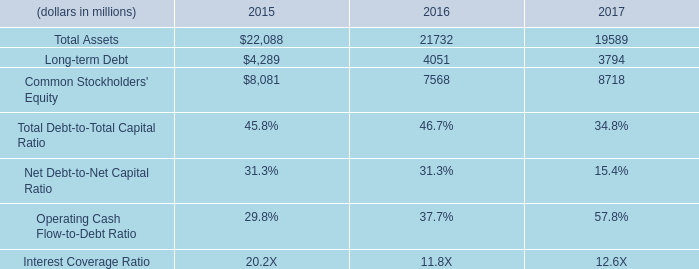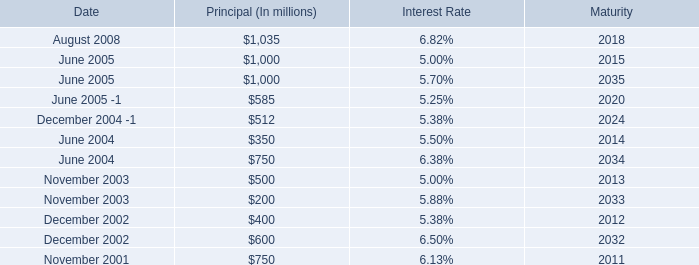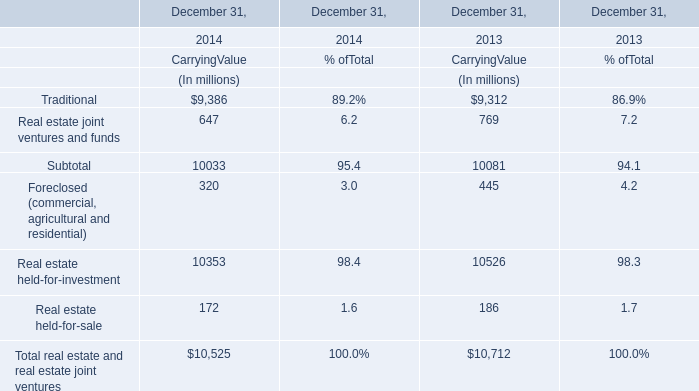What is the sum of December 2002 of Maturity, and Common Stockholders' Equity of 2017 ? 
Computations: (2032.0 + 8718.0)
Answer: 10750.0. 